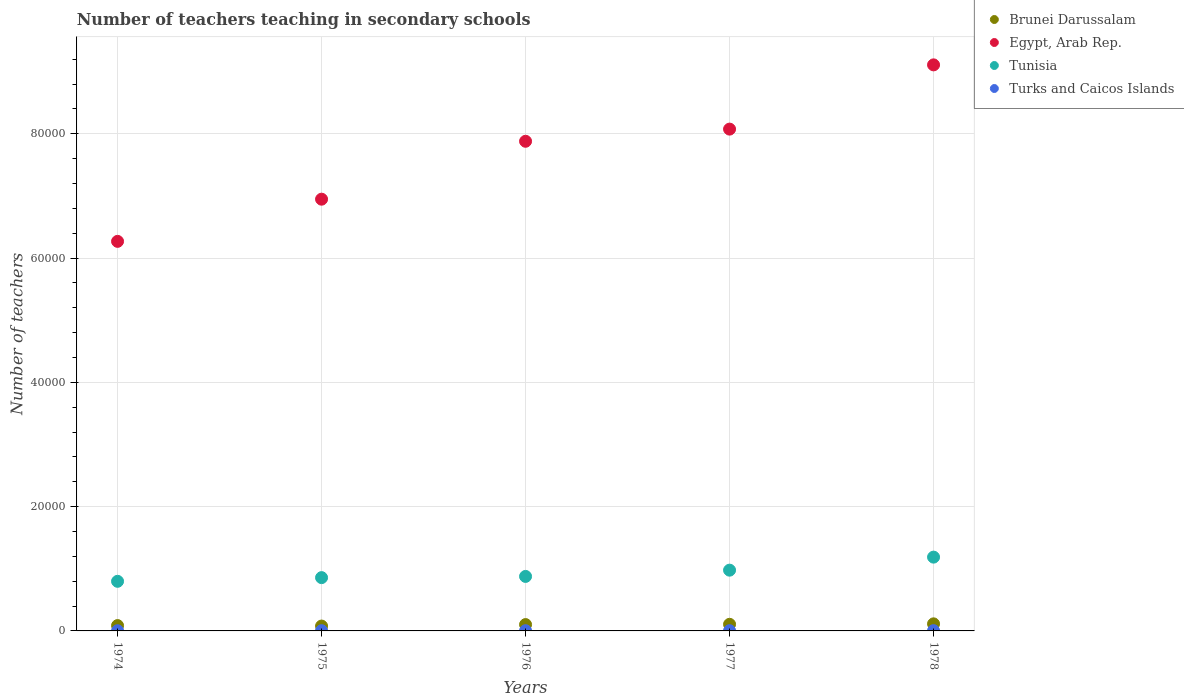Is the number of dotlines equal to the number of legend labels?
Your answer should be compact. Yes. What is the number of teachers teaching in secondary schools in Tunisia in 1975?
Ensure brevity in your answer.  8575. Across all years, what is the maximum number of teachers teaching in secondary schools in Brunei Darussalam?
Your response must be concise. 1138. In which year was the number of teachers teaching in secondary schools in Tunisia maximum?
Ensure brevity in your answer.  1978. In which year was the number of teachers teaching in secondary schools in Turks and Caicos Islands minimum?
Give a very brief answer. 1974. What is the total number of teachers teaching in secondary schools in Brunei Darussalam in the graph?
Your answer should be compact. 4865. What is the difference between the number of teachers teaching in secondary schools in Egypt, Arab Rep. in 1975 and that in 1976?
Keep it short and to the point. -9319. What is the difference between the number of teachers teaching in secondary schools in Brunei Darussalam in 1975 and the number of teachers teaching in secondary schools in Turks and Caicos Islands in 1974?
Offer a terse response. 752. What is the average number of teachers teaching in secondary schools in Egypt, Arab Rep. per year?
Provide a short and direct response. 7.66e+04. In the year 1977, what is the difference between the number of teachers teaching in secondary schools in Turks and Caicos Islands and number of teachers teaching in secondary schools in Brunei Darussalam?
Your response must be concise. -1027. In how many years, is the number of teachers teaching in secondary schools in Brunei Darussalam greater than 52000?
Provide a short and direct response. 0. What is the ratio of the number of teachers teaching in secondary schools in Egypt, Arab Rep. in 1974 to that in 1977?
Give a very brief answer. 0.78. Is the number of teachers teaching in secondary schools in Brunei Darussalam in 1977 less than that in 1978?
Provide a short and direct response. Yes. What is the difference between the highest and the second highest number of teachers teaching in secondary schools in Turks and Caicos Islands?
Make the answer very short. 5. In how many years, is the number of teachers teaching in secondary schools in Turks and Caicos Islands greater than the average number of teachers teaching in secondary schools in Turks and Caicos Islands taken over all years?
Provide a succinct answer. 2. Is it the case that in every year, the sum of the number of teachers teaching in secondary schools in Tunisia and number of teachers teaching in secondary schools in Brunei Darussalam  is greater than the sum of number of teachers teaching in secondary schools in Egypt, Arab Rep. and number of teachers teaching in secondary schools in Turks and Caicos Islands?
Provide a succinct answer. Yes. Is it the case that in every year, the sum of the number of teachers teaching in secondary schools in Brunei Darussalam and number of teachers teaching in secondary schools in Turks and Caicos Islands  is greater than the number of teachers teaching in secondary schools in Tunisia?
Make the answer very short. No. How many dotlines are there?
Your answer should be compact. 4. How many years are there in the graph?
Your answer should be very brief. 5. What is the difference between two consecutive major ticks on the Y-axis?
Make the answer very short. 2.00e+04. Are the values on the major ticks of Y-axis written in scientific E-notation?
Your answer should be compact. No. Does the graph contain any zero values?
Give a very brief answer. No. Does the graph contain grids?
Ensure brevity in your answer.  Yes. Where does the legend appear in the graph?
Your answer should be very brief. Top right. What is the title of the graph?
Your response must be concise. Number of teachers teaching in secondary schools. Does "Isle of Man" appear as one of the legend labels in the graph?
Provide a short and direct response. No. What is the label or title of the X-axis?
Offer a very short reply. Years. What is the label or title of the Y-axis?
Your answer should be compact. Number of teachers. What is the Number of teachers of Brunei Darussalam in 1974?
Give a very brief answer. 859. What is the Number of teachers of Egypt, Arab Rep. in 1974?
Give a very brief answer. 6.27e+04. What is the Number of teachers of Tunisia in 1974?
Your answer should be compact. 7983. What is the Number of teachers of Brunei Darussalam in 1975?
Make the answer very short. 782. What is the Number of teachers in Egypt, Arab Rep. in 1975?
Keep it short and to the point. 6.95e+04. What is the Number of teachers of Tunisia in 1975?
Ensure brevity in your answer.  8575. What is the Number of teachers in Brunei Darussalam in 1976?
Give a very brief answer. 1021. What is the Number of teachers of Egypt, Arab Rep. in 1976?
Make the answer very short. 7.88e+04. What is the Number of teachers in Tunisia in 1976?
Make the answer very short. 8769. What is the Number of teachers of Turks and Caicos Islands in 1976?
Ensure brevity in your answer.  35. What is the Number of teachers of Brunei Darussalam in 1977?
Offer a very short reply. 1065. What is the Number of teachers in Egypt, Arab Rep. in 1977?
Your answer should be very brief. 8.07e+04. What is the Number of teachers in Tunisia in 1977?
Provide a short and direct response. 9776. What is the Number of teachers of Brunei Darussalam in 1978?
Provide a short and direct response. 1138. What is the Number of teachers of Egypt, Arab Rep. in 1978?
Ensure brevity in your answer.  9.11e+04. What is the Number of teachers of Tunisia in 1978?
Your answer should be very brief. 1.19e+04. What is the Number of teachers of Turks and Caicos Islands in 1978?
Your answer should be very brief. 43. Across all years, what is the maximum Number of teachers of Brunei Darussalam?
Keep it short and to the point. 1138. Across all years, what is the maximum Number of teachers of Egypt, Arab Rep.?
Your response must be concise. 9.11e+04. Across all years, what is the maximum Number of teachers of Tunisia?
Make the answer very short. 1.19e+04. Across all years, what is the maximum Number of teachers of Turks and Caicos Islands?
Your answer should be compact. 43. Across all years, what is the minimum Number of teachers in Brunei Darussalam?
Provide a succinct answer. 782. Across all years, what is the minimum Number of teachers in Egypt, Arab Rep.?
Your answer should be very brief. 6.27e+04. Across all years, what is the minimum Number of teachers of Tunisia?
Your answer should be compact. 7983. Across all years, what is the minimum Number of teachers of Turks and Caicos Islands?
Your answer should be very brief. 30. What is the total Number of teachers in Brunei Darussalam in the graph?
Provide a short and direct response. 4865. What is the total Number of teachers in Egypt, Arab Rep. in the graph?
Provide a succinct answer. 3.83e+05. What is the total Number of teachers of Tunisia in the graph?
Keep it short and to the point. 4.70e+04. What is the total Number of teachers in Turks and Caicos Islands in the graph?
Provide a succinct answer. 182. What is the difference between the Number of teachers in Egypt, Arab Rep. in 1974 and that in 1975?
Make the answer very short. -6786. What is the difference between the Number of teachers in Tunisia in 1974 and that in 1975?
Ensure brevity in your answer.  -592. What is the difference between the Number of teachers in Brunei Darussalam in 1974 and that in 1976?
Provide a succinct answer. -162. What is the difference between the Number of teachers of Egypt, Arab Rep. in 1974 and that in 1976?
Your answer should be very brief. -1.61e+04. What is the difference between the Number of teachers in Tunisia in 1974 and that in 1976?
Ensure brevity in your answer.  -786. What is the difference between the Number of teachers in Turks and Caicos Islands in 1974 and that in 1976?
Offer a terse response. -5. What is the difference between the Number of teachers in Brunei Darussalam in 1974 and that in 1977?
Offer a terse response. -206. What is the difference between the Number of teachers of Egypt, Arab Rep. in 1974 and that in 1977?
Ensure brevity in your answer.  -1.81e+04. What is the difference between the Number of teachers in Tunisia in 1974 and that in 1977?
Your response must be concise. -1793. What is the difference between the Number of teachers in Brunei Darussalam in 1974 and that in 1978?
Ensure brevity in your answer.  -279. What is the difference between the Number of teachers of Egypt, Arab Rep. in 1974 and that in 1978?
Offer a terse response. -2.84e+04. What is the difference between the Number of teachers of Tunisia in 1974 and that in 1978?
Make the answer very short. -3891. What is the difference between the Number of teachers of Turks and Caicos Islands in 1974 and that in 1978?
Offer a terse response. -13. What is the difference between the Number of teachers of Brunei Darussalam in 1975 and that in 1976?
Provide a succinct answer. -239. What is the difference between the Number of teachers of Egypt, Arab Rep. in 1975 and that in 1976?
Provide a short and direct response. -9319. What is the difference between the Number of teachers of Tunisia in 1975 and that in 1976?
Give a very brief answer. -194. What is the difference between the Number of teachers in Turks and Caicos Islands in 1975 and that in 1976?
Ensure brevity in your answer.  1. What is the difference between the Number of teachers in Brunei Darussalam in 1975 and that in 1977?
Offer a terse response. -283. What is the difference between the Number of teachers in Egypt, Arab Rep. in 1975 and that in 1977?
Make the answer very short. -1.13e+04. What is the difference between the Number of teachers in Tunisia in 1975 and that in 1977?
Provide a short and direct response. -1201. What is the difference between the Number of teachers of Turks and Caicos Islands in 1975 and that in 1977?
Your response must be concise. -2. What is the difference between the Number of teachers of Brunei Darussalam in 1975 and that in 1978?
Provide a short and direct response. -356. What is the difference between the Number of teachers in Egypt, Arab Rep. in 1975 and that in 1978?
Offer a terse response. -2.16e+04. What is the difference between the Number of teachers of Tunisia in 1975 and that in 1978?
Provide a succinct answer. -3299. What is the difference between the Number of teachers of Turks and Caicos Islands in 1975 and that in 1978?
Your answer should be very brief. -7. What is the difference between the Number of teachers of Brunei Darussalam in 1976 and that in 1977?
Provide a short and direct response. -44. What is the difference between the Number of teachers of Egypt, Arab Rep. in 1976 and that in 1977?
Make the answer very short. -1956. What is the difference between the Number of teachers in Tunisia in 1976 and that in 1977?
Keep it short and to the point. -1007. What is the difference between the Number of teachers of Brunei Darussalam in 1976 and that in 1978?
Provide a succinct answer. -117. What is the difference between the Number of teachers of Egypt, Arab Rep. in 1976 and that in 1978?
Ensure brevity in your answer.  -1.23e+04. What is the difference between the Number of teachers of Tunisia in 1976 and that in 1978?
Provide a succinct answer. -3105. What is the difference between the Number of teachers in Brunei Darussalam in 1977 and that in 1978?
Your answer should be very brief. -73. What is the difference between the Number of teachers of Egypt, Arab Rep. in 1977 and that in 1978?
Your answer should be very brief. -1.03e+04. What is the difference between the Number of teachers in Tunisia in 1977 and that in 1978?
Your answer should be compact. -2098. What is the difference between the Number of teachers in Turks and Caicos Islands in 1977 and that in 1978?
Provide a short and direct response. -5. What is the difference between the Number of teachers of Brunei Darussalam in 1974 and the Number of teachers of Egypt, Arab Rep. in 1975?
Your answer should be compact. -6.86e+04. What is the difference between the Number of teachers in Brunei Darussalam in 1974 and the Number of teachers in Tunisia in 1975?
Make the answer very short. -7716. What is the difference between the Number of teachers in Brunei Darussalam in 1974 and the Number of teachers in Turks and Caicos Islands in 1975?
Your answer should be compact. 823. What is the difference between the Number of teachers in Egypt, Arab Rep. in 1974 and the Number of teachers in Tunisia in 1975?
Your answer should be very brief. 5.41e+04. What is the difference between the Number of teachers of Egypt, Arab Rep. in 1974 and the Number of teachers of Turks and Caicos Islands in 1975?
Provide a short and direct response. 6.26e+04. What is the difference between the Number of teachers in Tunisia in 1974 and the Number of teachers in Turks and Caicos Islands in 1975?
Give a very brief answer. 7947. What is the difference between the Number of teachers in Brunei Darussalam in 1974 and the Number of teachers in Egypt, Arab Rep. in 1976?
Ensure brevity in your answer.  -7.79e+04. What is the difference between the Number of teachers in Brunei Darussalam in 1974 and the Number of teachers in Tunisia in 1976?
Your answer should be compact. -7910. What is the difference between the Number of teachers in Brunei Darussalam in 1974 and the Number of teachers in Turks and Caicos Islands in 1976?
Ensure brevity in your answer.  824. What is the difference between the Number of teachers of Egypt, Arab Rep. in 1974 and the Number of teachers of Tunisia in 1976?
Your answer should be compact. 5.39e+04. What is the difference between the Number of teachers of Egypt, Arab Rep. in 1974 and the Number of teachers of Turks and Caicos Islands in 1976?
Ensure brevity in your answer.  6.26e+04. What is the difference between the Number of teachers in Tunisia in 1974 and the Number of teachers in Turks and Caicos Islands in 1976?
Give a very brief answer. 7948. What is the difference between the Number of teachers of Brunei Darussalam in 1974 and the Number of teachers of Egypt, Arab Rep. in 1977?
Provide a succinct answer. -7.99e+04. What is the difference between the Number of teachers of Brunei Darussalam in 1974 and the Number of teachers of Tunisia in 1977?
Offer a terse response. -8917. What is the difference between the Number of teachers of Brunei Darussalam in 1974 and the Number of teachers of Turks and Caicos Islands in 1977?
Give a very brief answer. 821. What is the difference between the Number of teachers in Egypt, Arab Rep. in 1974 and the Number of teachers in Tunisia in 1977?
Your answer should be compact. 5.29e+04. What is the difference between the Number of teachers in Egypt, Arab Rep. in 1974 and the Number of teachers in Turks and Caicos Islands in 1977?
Provide a succinct answer. 6.26e+04. What is the difference between the Number of teachers in Tunisia in 1974 and the Number of teachers in Turks and Caicos Islands in 1977?
Give a very brief answer. 7945. What is the difference between the Number of teachers of Brunei Darussalam in 1974 and the Number of teachers of Egypt, Arab Rep. in 1978?
Ensure brevity in your answer.  -9.02e+04. What is the difference between the Number of teachers of Brunei Darussalam in 1974 and the Number of teachers of Tunisia in 1978?
Your response must be concise. -1.10e+04. What is the difference between the Number of teachers of Brunei Darussalam in 1974 and the Number of teachers of Turks and Caicos Islands in 1978?
Offer a terse response. 816. What is the difference between the Number of teachers of Egypt, Arab Rep. in 1974 and the Number of teachers of Tunisia in 1978?
Your answer should be compact. 5.08e+04. What is the difference between the Number of teachers of Egypt, Arab Rep. in 1974 and the Number of teachers of Turks and Caicos Islands in 1978?
Give a very brief answer. 6.26e+04. What is the difference between the Number of teachers of Tunisia in 1974 and the Number of teachers of Turks and Caicos Islands in 1978?
Provide a succinct answer. 7940. What is the difference between the Number of teachers of Brunei Darussalam in 1975 and the Number of teachers of Egypt, Arab Rep. in 1976?
Provide a short and direct response. -7.80e+04. What is the difference between the Number of teachers in Brunei Darussalam in 1975 and the Number of teachers in Tunisia in 1976?
Make the answer very short. -7987. What is the difference between the Number of teachers in Brunei Darussalam in 1975 and the Number of teachers in Turks and Caicos Islands in 1976?
Offer a terse response. 747. What is the difference between the Number of teachers in Egypt, Arab Rep. in 1975 and the Number of teachers in Tunisia in 1976?
Keep it short and to the point. 6.07e+04. What is the difference between the Number of teachers in Egypt, Arab Rep. in 1975 and the Number of teachers in Turks and Caicos Islands in 1976?
Provide a short and direct response. 6.94e+04. What is the difference between the Number of teachers in Tunisia in 1975 and the Number of teachers in Turks and Caicos Islands in 1976?
Keep it short and to the point. 8540. What is the difference between the Number of teachers in Brunei Darussalam in 1975 and the Number of teachers in Egypt, Arab Rep. in 1977?
Offer a very short reply. -8.00e+04. What is the difference between the Number of teachers of Brunei Darussalam in 1975 and the Number of teachers of Tunisia in 1977?
Make the answer very short. -8994. What is the difference between the Number of teachers of Brunei Darussalam in 1975 and the Number of teachers of Turks and Caicos Islands in 1977?
Provide a short and direct response. 744. What is the difference between the Number of teachers in Egypt, Arab Rep. in 1975 and the Number of teachers in Tunisia in 1977?
Your response must be concise. 5.97e+04. What is the difference between the Number of teachers in Egypt, Arab Rep. in 1975 and the Number of teachers in Turks and Caicos Islands in 1977?
Ensure brevity in your answer.  6.94e+04. What is the difference between the Number of teachers of Tunisia in 1975 and the Number of teachers of Turks and Caicos Islands in 1977?
Your response must be concise. 8537. What is the difference between the Number of teachers of Brunei Darussalam in 1975 and the Number of teachers of Egypt, Arab Rep. in 1978?
Keep it short and to the point. -9.03e+04. What is the difference between the Number of teachers in Brunei Darussalam in 1975 and the Number of teachers in Tunisia in 1978?
Provide a short and direct response. -1.11e+04. What is the difference between the Number of teachers of Brunei Darussalam in 1975 and the Number of teachers of Turks and Caicos Islands in 1978?
Keep it short and to the point. 739. What is the difference between the Number of teachers in Egypt, Arab Rep. in 1975 and the Number of teachers in Tunisia in 1978?
Provide a short and direct response. 5.76e+04. What is the difference between the Number of teachers in Egypt, Arab Rep. in 1975 and the Number of teachers in Turks and Caicos Islands in 1978?
Provide a short and direct response. 6.94e+04. What is the difference between the Number of teachers of Tunisia in 1975 and the Number of teachers of Turks and Caicos Islands in 1978?
Make the answer very short. 8532. What is the difference between the Number of teachers of Brunei Darussalam in 1976 and the Number of teachers of Egypt, Arab Rep. in 1977?
Provide a short and direct response. -7.97e+04. What is the difference between the Number of teachers in Brunei Darussalam in 1976 and the Number of teachers in Tunisia in 1977?
Ensure brevity in your answer.  -8755. What is the difference between the Number of teachers in Brunei Darussalam in 1976 and the Number of teachers in Turks and Caicos Islands in 1977?
Keep it short and to the point. 983. What is the difference between the Number of teachers of Egypt, Arab Rep. in 1976 and the Number of teachers of Tunisia in 1977?
Keep it short and to the point. 6.90e+04. What is the difference between the Number of teachers of Egypt, Arab Rep. in 1976 and the Number of teachers of Turks and Caicos Islands in 1977?
Ensure brevity in your answer.  7.88e+04. What is the difference between the Number of teachers in Tunisia in 1976 and the Number of teachers in Turks and Caicos Islands in 1977?
Provide a short and direct response. 8731. What is the difference between the Number of teachers of Brunei Darussalam in 1976 and the Number of teachers of Egypt, Arab Rep. in 1978?
Your answer should be compact. -9.01e+04. What is the difference between the Number of teachers of Brunei Darussalam in 1976 and the Number of teachers of Tunisia in 1978?
Provide a short and direct response. -1.09e+04. What is the difference between the Number of teachers in Brunei Darussalam in 1976 and the Number of teachers in Turks and Caicos Islands in 1978?
Your answer should be compact. 978. What is the difference between the Number of teachers in Egypt, Arab Rep. in 1976 and the Number of teachers in Tunisia in 1978?
Keep it short and to the point. 6.69e+04. What is the difference between the Number of teachers of Egypt, Arab Rep. in 1976 and the Number of teachers of Turks and Caicos Islands in 1978?
Offer a very short reply. 7.87e+04. What is the difference between the Number of teachers of Tunisia in 1976 and the Number of teachers of Turks and Caicos Islands in 1978?
Offer a very short reply. 8726. What is the difference between the Number of teachers of Brunei Darussalam in 1977 and the Number of teachers of Egypt, Arab Rep. in 1978?
Your response must be concise. -9.00e+04. What is the difference between the Number of teachers in Brunei Darussalam in 1977 and the Number of teachers in Tunisia in 1978?
Make the answer very short. -1.08e+04. What is the difference between the Number of teachers in Brunei Darussalam in 1977 and the Number of teachers in Turks and Caicos Islands in 1978?
Your response must be concise. 1022. What is the difference between the Number of teachers in Egypt, Arab Rep. in 1977 and the Number of teachers in Tunisia in 1978?
Your answer should be compact. 6.89e+04. What is the difference between the Number of teachers of Egypt, Arab Rep. in 1977 and the Number of teachers of Turks and Caicos Islands in 1978?
Offer a terse response. 8.07e+04. What is the difference between the Number of teachers of Tunisia in 1977 and the Number of teachers of Turks and Caicos Islands in 1978?
Your answer should be very brief. 9733. What is the average Number of teachers of Brunei Darussalam per year?
Keep it short and to the point. 973. What is the average Number of teachers of Egypt, Arab Rep. per year?
Provide a succinct answer. 7.66e+04. What is the average Number of teachers of Tunisia per year?
Your answer should be very brief. 9395.4. What is the average Number of teachers in Turks and Caicos Islands per year?
Your response must be concise. 36.4. In the year 1974, what is the difference between the Number of teachers of Brunei Darussalam and Number of teachers of Egypt, Arab Rep.?
Offer a terse response. -6.18e+04. In the year 1974, what is the difference between the Number of teachers in Brunei Darussalam and Number of teachers in Tunisia?
Your answer should be compact. -7124. In the year 1974, what is the difference between the Number of teachers of Brunei Darussalam and Number of teachers of Turks and Caicos Islands?
Give a very brief answer. 829. In the year 1974, what is the difference between the Number of teachers of Egypt, Arab Rep. and Number of teachers of Tunisia?
Provide a short and direct response. 5.47e+04. In the year 1974, what is the difference between the Number of teachers of Egypt, Arab Rep. and Number of teachers of Turks and Caicos Islands?
Your answer should be compact. 6.27e+04. In the year 1974, what is the difference between the Number of teachers in Tunisia and Number of teachers in Turks and Caicos Islands?
Your response must be concise. 7953. In the year 1975, what is the difference between the Number of teachers of Brunei Darussalam and Number of teachers of Egypt, Arab Rep.?
Offer a very short reply. -6.87e+04. In the year 1975, what is the difference between the Number of teachers in Brunei Darussalam and Number of teachers in Tunisia?
Keep it short and to the point. -7793. In the year 1975, what is the difference between the Number of teachers of Brunei Darussalam and Number of teachers of Turks and Caicos Islands?
Ensure brevity in your answer.  746. In the year 1975, what is the difference between the Number of teachers of Egypt, Arab Rep. and Number of teachers of Tunisia?
Your response must be concise. 6.09e+04. In the year 1975, what is the difference between the Number of teachers of Egypt, Arab Rep. and Number of teachers of Turks and Caicos Islands?
Ensure brevity in your answer.  6.94e+04. In the year 1975, what is the difference between the Number of teachers in Tunisia and Number of teachers in Turks and Caicos Islands?
Provide a short and direct response. 8539. In the year 1976, what is the difference between the Number of teachers of Brunei Darussalam and Number of teachers of Egypt, Arab Rep.?
Provide a succinct answer. -7.78e+04. In the year 1976, what is the difference between the Number of teachers in Brunei Darussalam and Number of teachers in Tunisia?
Your response must be concise. -7748. In the year 1976, what is the difference between the Number of teachers of Brunei Darussalam and Number of teachers of Turks and Caicos Islands?
Offer a terse response. 986. In the year 1976, what is the difference between the Number of teachers in Egypt, Arab Rep. and Number of teachers in Tunisia?
Keep it short and to the point. 7.00e+04. In the year 1976, what is the difference between the Number of teachers of Egypt, Arab Rep. and Number of teachers of Turks and Caicos Islands?
Your answer should be very brief. 7.88e+04. In the year 1976, what is the difference between the Number of teachers of Tunisia and Number of teachers of Turks and Caicos Islands?
Give a very brief answer. 8734. In the year 1977, what is the difference between the Number of teachers in Brunei Darussalam and Number of teachers in Egypt, Arab Rep.?
Offer a very short reply. -7.97e+04. In the year 1977, what is the difference between the Number of teachers of Brunei Darussalam and Number of teachers of Tunisia?
Your response must be concise. -8711. In the year 1977, what is the difference between the Number of teachers of Brunei Darussalam and Number of teachers of Turks and Caicos Islands?
Offer a very short reply. 1027. In the year 1977, what is the difference between the Number of teachers in Egypt, Arab Rep. and Number of teachers in Tunisia?
Give a very brief answer. 7.10e+04. In the year 1977, what is the difference between the Number of teachers of Egypt, Arab Rep. and Number of teachers of Turks and Caicos Islands?
Provide a short and direct response. 8.07e+04. In the year 1977, what is the difference between the Number of teachers in Tunisia and Number of teachers in Turks and Caicos Islands?
Give a very brief answer. 9738. In the year 1978, what is the difference between the Number of teachers of Brunei Darussalam and Number of teachers of Egypt, Arab Rep.?
Offer a very short reply. -8.99e+04. In the year 1978, what is the difference between the Number of teachers in Brunei Darussalam and Number of teachers in Tunisia?
Keep it short and to the point. -1.07e+04. In the year 1978, what is the difference between the Number of teachers in Brunei Darussalam and Number of teachers in Turks and Caicos Islands?
Make the answer very short. 1095. In the year 1978, what is the difference between the Number of teachers of Egypt, Arab Rep. and Number of teachers of Tunisia?
Offer a very short reply. 7.92e+04. In the year 1978, what is the difference between the Number of teachers in Egypt, Arab Rep. and Number of teachers in Turks and Caicos Islands?
Offer a terse response. 9.10e+04. In the year 1978, what is the difference between the Number of teachers of Tunisia and Number of teachers of Turks and Caicos Islands?
Keep it short and to the point. 1.18e+04. What is the ratio of the Number of teachers in Brunei Darussalam in 1974 to that in 1975?
Keep it short and to the point. 1.1. What is the ratio of the Number of teachers in Egypt, Arab Rep. in 1974 to that in 1975?
Provide a succinct answer. 0.9. What is the ratio of the Number of teachers of Tunisia in 1974 to that in 1975?
Keep it short and to the point. 0.93. What is the ratio of the Number of teachers of Turks and Caicos Islands in 1974 to that in 1975?
Make the answer very short. 0.83. What is the ratio of the Number of teachers in Brunei Darussalam in 1974 to that in 1976?
Your answer should be very brief. 0.84. What is the ratio of the Number of teachers in Egypt, Arab Rep. in 1974 to that in 1976?
Offer a very short reply. 0.8. What is the ratio of the Number of teachers of Tunisia in 1974 to that in 1976?
Offer a terse response. 0.91. What is the ratio of the Number of teachers in Brunei Darussalam in 1974 to that in 1977?
Offer a very short reply. 0.81. What is the ratio of the Number of teachers of Egypt, Arab Rep. in 1974 to that in 1977?
Keep it short and to the point. 0.78. What is the ratio of the Number of teachers of Tunisia in 1974 to that in 1977?
Give a very brief answer. 0.82. What is the ratio of the Number of teachers of Turks and Caicos Islands in 1974 to that in 1977?
Provide a succinct answer. 0.79. What is the ratio of the Number of teachers in Brunei Darussalam in 1974 to that in 1978?
Your answer should be compact. 0.75. What is the ratio of the Number of teachers in Egypt, Arab Rep. in 1974 to that in 1978?
Give a very brief answer. 0.69. What is the ratio of the Number of teachers of Tunisia in 1974 to that in 1978?
Provide a succinct answer. 0.67. What is the ratio of the Number of teachers in Turks and Caicos Islands in 1974 to that in 1978?
Provide a succinct answer. 0.7. What is the ratio of the Number of teachers in Brunei Darussalam in 1975 to that in 1976?
Offer a terse response. 0.77. What is the ratio of the Number of teachers in Egypt, Arab Rep. in 1975 to that in 1976?
Offer a terse response. 0.88. What is the ratio of the Number of teachers of Tunisia in 1975 to that in 1976?
Provide a short and direct response. 0.98. What is the ratio of the Number of teachers of Turks and Caicos Islands in 1975 to that in 1976?
Make the answer very short. 1.03. What is the ratio of the Number of teachers of Brunei Darussalam in 1975 to that in 1977?
Keep it short and to the point. 0.73. What is the ratio of the Number of teachers in Egypt, Arab Rep. in 1975 to that in 1977?
Your response must be concise. 0.86. What is the ratio of the Number of teachers in Tunisia in 1975 to that in 1977?
Your response must be concise. 0.88. What is the ratio of the Number of teachers of Turks and Caicos Islands in 1975 to that in 1977?
Your answer should be compact. 0.95. What is the ratio of the Number of teachers of Brunei Darussalam in 1975 to that in 1978?
Offer a very short reply. 0.69. What is the ratio of the Number of teachers in Egypt, Arab Rep. in 1975 to that in 1978?
Ensure brevity in your answer.  0.76. What is the ratio of the Number of teachers in Tunisia in 1975 to that in 1978?
Your answer should be very brief. 0.72. What is the ratio of the Number of teachers in Turks and Caicos Islands in 1975 to that in 1978?
Your response must be concise. 0.84. What is the ratio of the Number of teachers in Brunei Darussalam in 1976 to that in 1977?
Provide a short and direct response. 0.96. What is the ratio of the Number of teachers of Egypt, Arab Rep. in 1976 to that in 1977?
Give a very brief answer. 0.98. What is the ratio of the Number of teachers of Tunisia in 1976 to that in 1977?
Provide a succinct answer. 0.9. What is the ratio of the Number of teachers of Turks and Caicos Islands in 1976 to that in 1977?
Offer a terse response. 0.92. What is the ratio of the Number of teachers in Brunei Darussalam in 1976 to that in 1978?
Your answer should be very brief. 0.9. What is the ratio of the Number of teachers of Egypt, Arab Rep. in 1976 to that in 1978?
Your response must be concise. 0.86. What is the ratio of the Number of teachers in Tunisia in 1976 to that in 1978?
Your response must be concise. 0.74. What is the ratio of the Number of teachers in Turks and Caicos Islands in 1976 to that in 1978?
Provide a succinct answer. 0.81. What is the ratio of the Number of teachers in Brunei Darussalam in 1977 to that in 1978?
Offer a terse response. 0.94. What is the ratio of the Number of teachers of Egypt, Arab Rep. in 1977 to that in 1978?
Your response must be concise. 0.89. What is the ratio of the Number of teachers of Tunisia in 1977 to that in 1978?
Give a very brief answer. 0.82. What is the ratio of the Number of teachers of Turks and Caicos Islands in 1977 to that in 1978?
Your answer should be compact. 0.88. What is the difference between the highest and the second highest Number of teachers in Brunei Darussalam?
Ensure brevity in your answer.  73. What is the difference between the highest and the second highest Number of teachers in Egypt, Arab Rep.?
Your response must be concise. 1.03e+04. What is the difference between the highest and the second highest Number of teachers in Tunisia?
Keep it short and to the point. 2098. What is the difference between the highest and the lowest Number of teachers in Brunei Darussalam?
Offer a very short reply. 356. What is the difference between the highest and the lowest Number of teachers in Egypt, Arab Rep.?
Keep it short and to the point. 2.84e+04. What is the difference between the highest and the lowest Number of teachers in Tunisia?
Your response must be concise. 3891. 